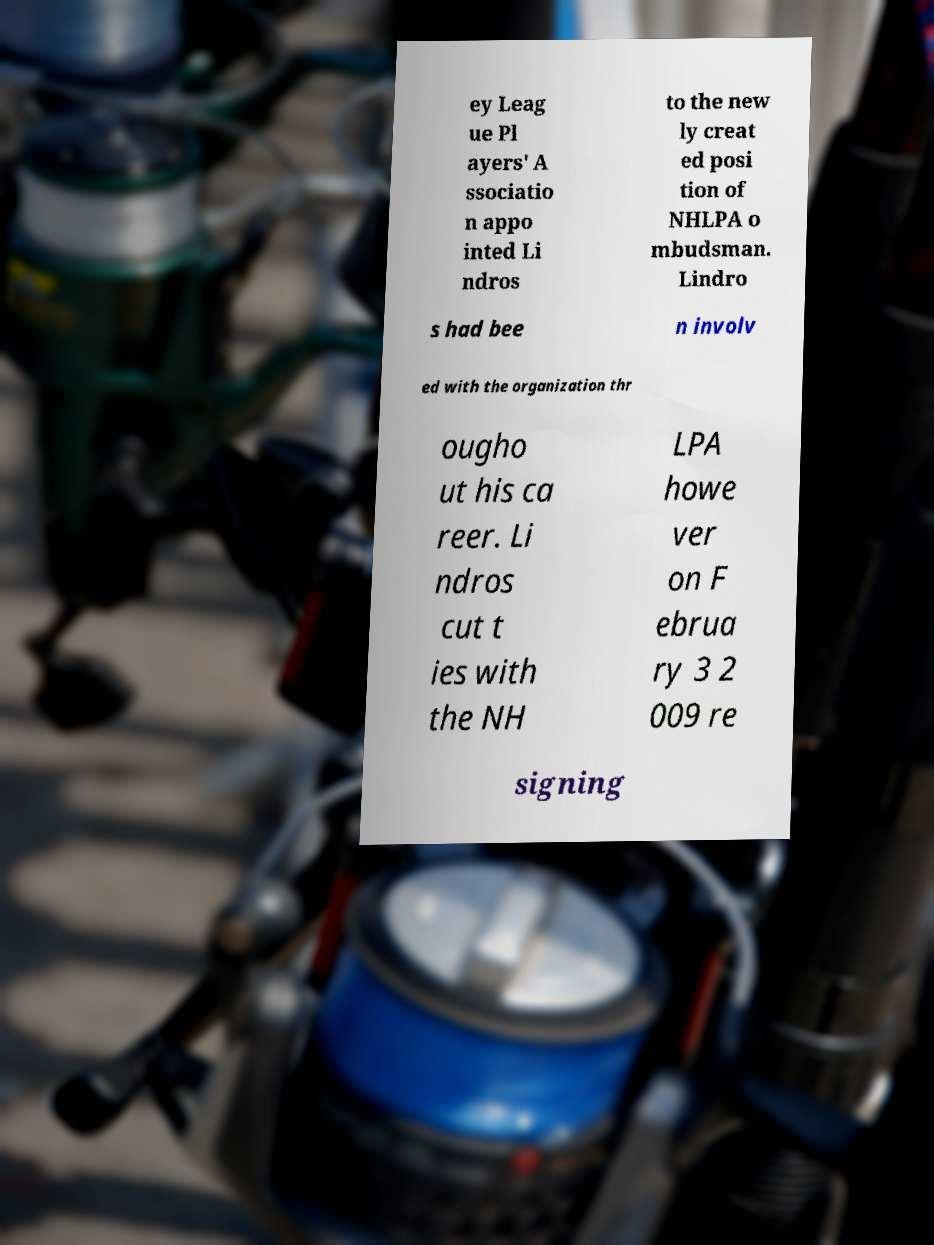What messages or text are displayed in this image? I need them in a readable, typed format. ey Leag ue Pl ayers' A ssociatio n appo inted Li ndros to the new ly creat ed posi tion of NHLPA o mbudsman. Lindro s had bee n involv ed with the organization thr ougho ut his ca reer. Li ndros cut t ies with the NH LPA howe ver on F ebrua ry 3 2 009 re signing 